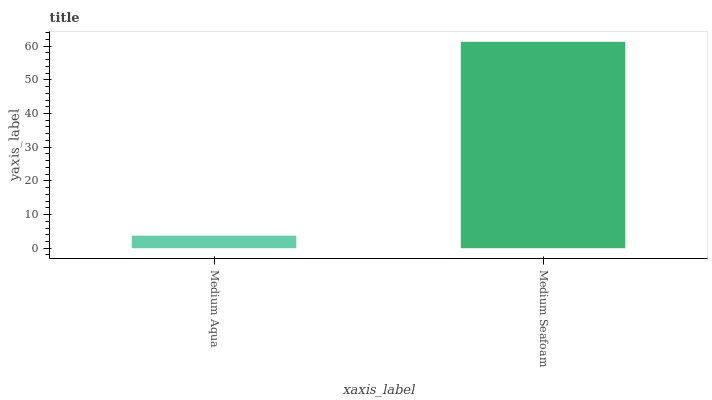Is Medium Aqua the minimum?
Answer yes or no. Yes. Is Medium Seafoam the maximum?
Answer yes or no. Yes. Is Medium Seafoam the minimum?
Answer yes or no. No. Is Medium Seafoam greater than Medium Aqua?
Answer yes or no. Yes. Is Medium Aqua less than Medium Seafoam?
Answer yes or no. Yes. Is Medium Aqua greater than Medium Seafoam?
Answer yes or no. No. Is Medium Seafoam less than Medium Aqua?
Answer yes or no. No. Is Medium Seafoam the high median?
Answer yes or no. Yes. Is Medium Aqua the low median?
Answer yes or no. Yes. Is Medium Aqua the high median?
Answer yes or no. No. Is Medium Seafoam the low median?
Answer yes or no. No. 